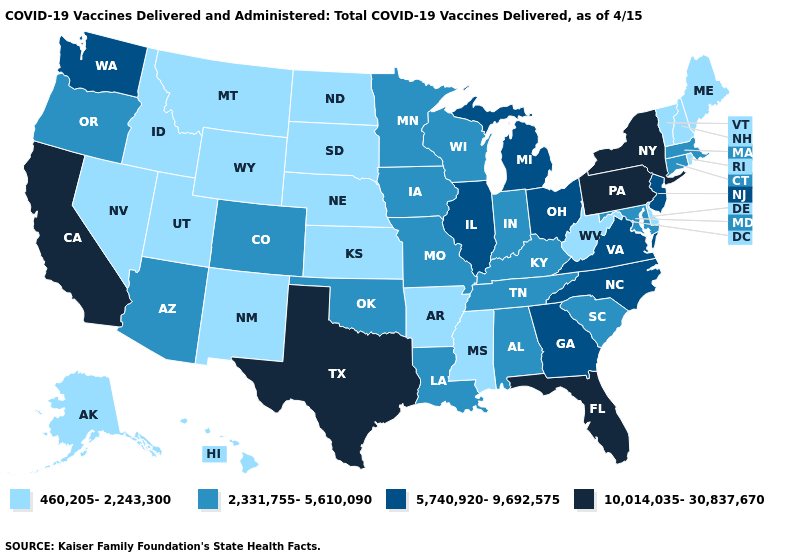Does Texas have the lowest value in the South?
Write a very short answer. No. Among the states that border North Carolina , which have the highest value?
Keep it brief. Georgia, Virginia. Which states have the lowest value in the USA?
Give a very brief answer. Alaska, Arkansas, Delaware, Hawaii, Idaho, Kansas, Maine, Mississippi, Montana, Nebraska, Nevada, New Hampshire, New Mexico, North Dakota, Rhode Island, South Dakota, Utah, Vermont, West Virginia, Wyoming. Does Alaska have the same value as Rhode Island?
Write a very short answer. Yes. What is the value of Oklahoma?
Write a very short answer. 2,331,755-5,610,090. Which states have the highest value in the USA?
Be succinct. California, Florida, New York, Pennsylvania, Texas. Name the states that have a value in the range 10,014,035-30,837,670?
Be succinct. California, Florida, New York, Pennsylvania, Texas. What is the highest value in the West ?
Concise answer only. 10,014,035-30,837,670. What is the value of California?
Write a very short answer. 10,014,035-30,837,670. Name the states that have a value in the range 10,014,035-30,837,670?
Keep it brief. California, Florida, New York, Pennsylvania, Texas. Which states have the lowest value in the South?
Answer briefly. Arkansas, Delaware, Mississippi, West Virginia. Which states have the lowest value in the USA?
Keep it brief. Alaska, Arkansas, Delaware, Hawaii, Idaho, Kansas, Maine, Mississippi, Montana, Nebraska, Nevada, New Hampshire, New Mexico, North Dakota, Rhode Island, South Dakota, Utah, Vermont, West Virginia, Wyoming. What is the value of Wisconsin?
Short answer required. 2,331,755-5,610,090. Does the first symbol in the legend represent the smallest category?
Give a very brief answer. Yes. What is the value of South Dakota?
Keep it brief. 460,205-2,243,300. 